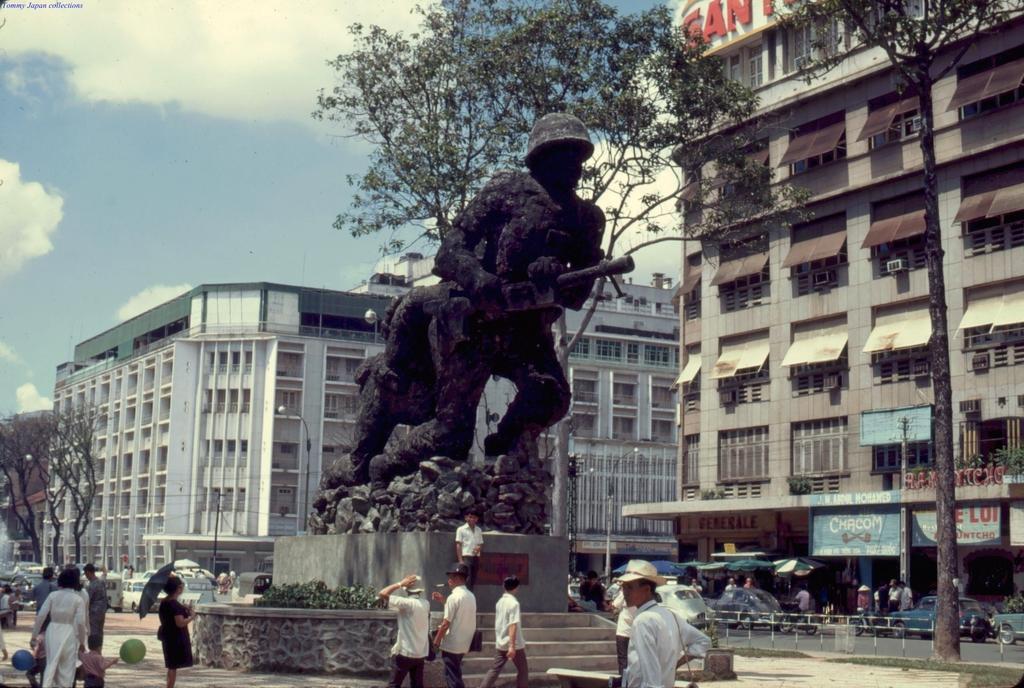Describe this image in one or two sentences. In the foreground of the picture there are people. In the center of the picture there is a sculpture. On the right there are people, umbrellas, road, vehicles, banners and a building. In the center of the background there are trees, vehicles, building and other objects. 